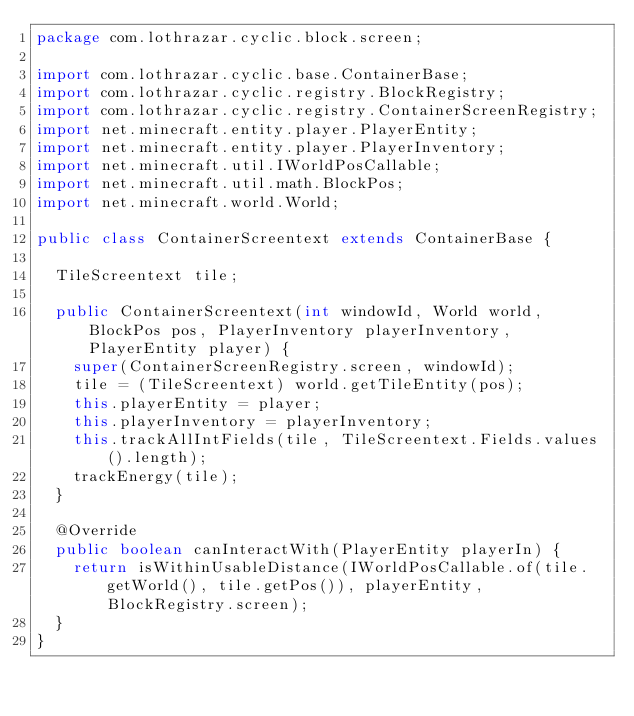<code> <loc_0><loc_0><loc_500><loc_500><_Java_>package com.lothrazar.cyclic.block.screen;

import com.lothrazar.cyclic.base.ContainerBase;
import com.lothrazar.cyclic.registry.BlockRegistry;
import com.lothrazar.cyclic.registry.ContainerScreenRegistry;
import net.minecraft.entity.player.PlayerEntity;
import net.minecraft.entity.player.PlayerInventory;
import net.minecraft.util.IWorldPosCallable;
import net.minecraft.util.math.BlockPos;
import net.minecraft.world.World;

public class ContainerScreentext extends ContainerBase {

  TileScreentext tile;

  public ContainerScreentext(int windowId, World world, BlockPos pos, PlayerInventory playerInventory, PlayerEntity player) {
    super(ContainerScreenRegistry.screen, windowId);
    tile = (TileScreentext) world.getTileEntity(pos);
    this.playerEntity = player;
    this.playerInventory = playerInventory;
    this.trackAllIntFields(tile, TileScreentext.Fields.values().length);
    trackEnergy(tile);
  }

  @Override
  public boolean canInteractWith(PlayerEntity playerIn) {
    return isWithinUsableDistance(IWorldPosCallable.of(tile.getWorld(), tile.getPos()), playerEntity, BlockRegistry.screen);
  }
}</code> 